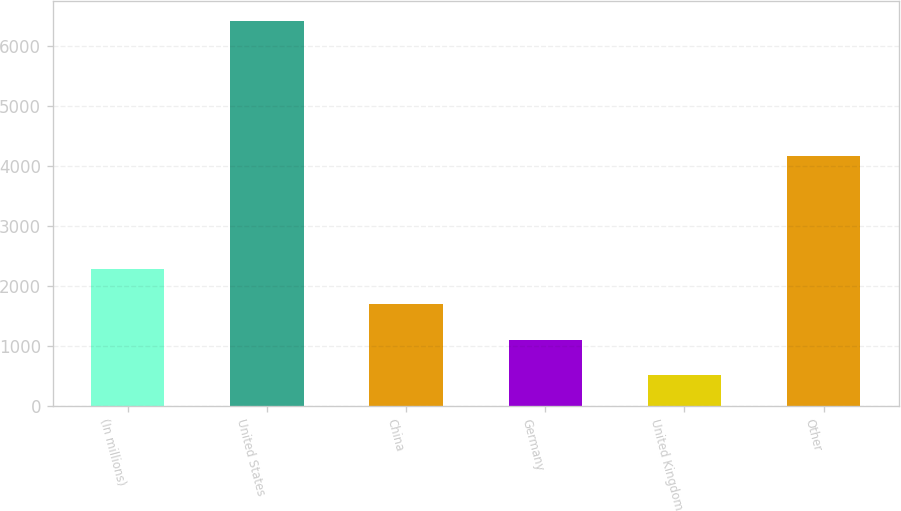Convert chart to OTSL. <chart><loc_0><loc_0><loc_500><loc_500><bar_chart><fcel>(In millions)<fcel>United States<fcel>China<fcel>Germany<fcel>United Kingdom<fcel>Other<nl><fcel>2282.29<fcel>6424.4<fcel>1690.56<fcel>1098.83<fcel>507.1<fcel>4161.1<nl></chart> 